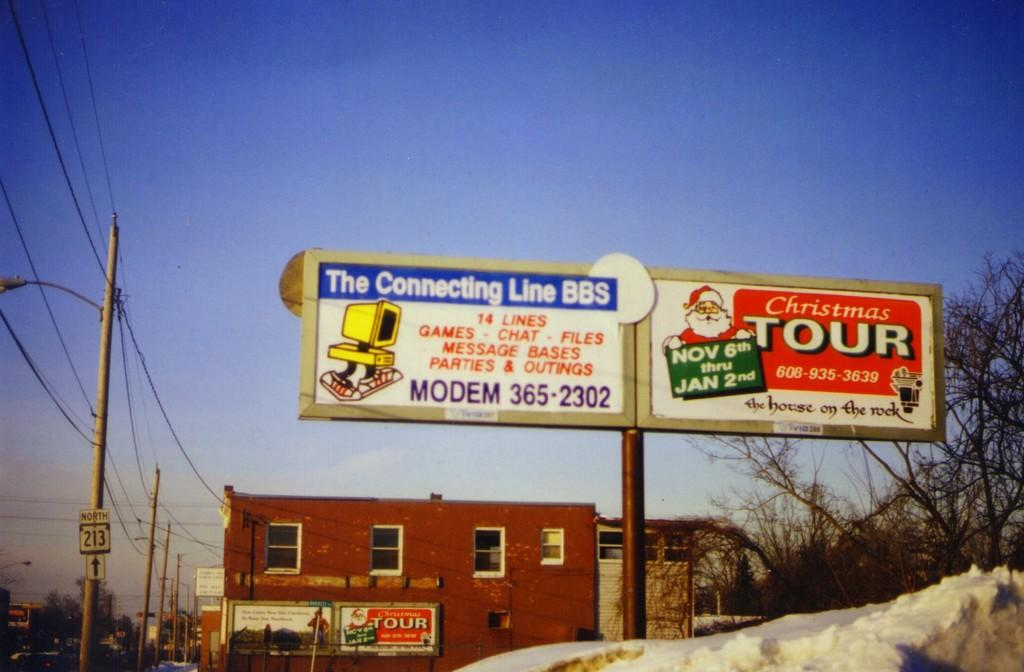<image>
Give a short and clear explanation of the subsequent image. A building with an advertising sign for the Connecting Line BBS and Christmas Tours. 